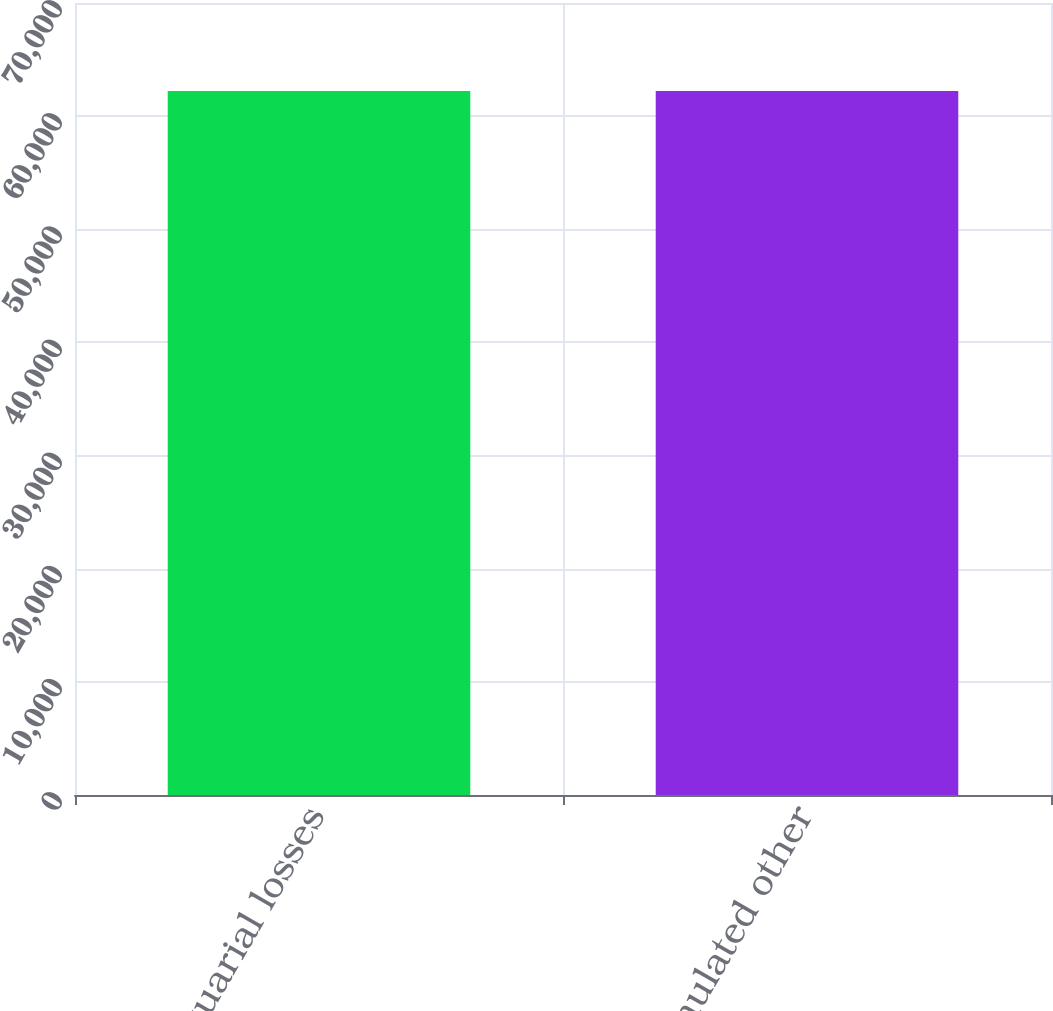Convert chart to OTSL. <chart><loc_0><loc_0><loc_500><loc_500><bar_chart><fcel>Actuarial losses<fcel>Accumulated other<nl><fcel>62226<fcel>62226.1<nl></chart> 